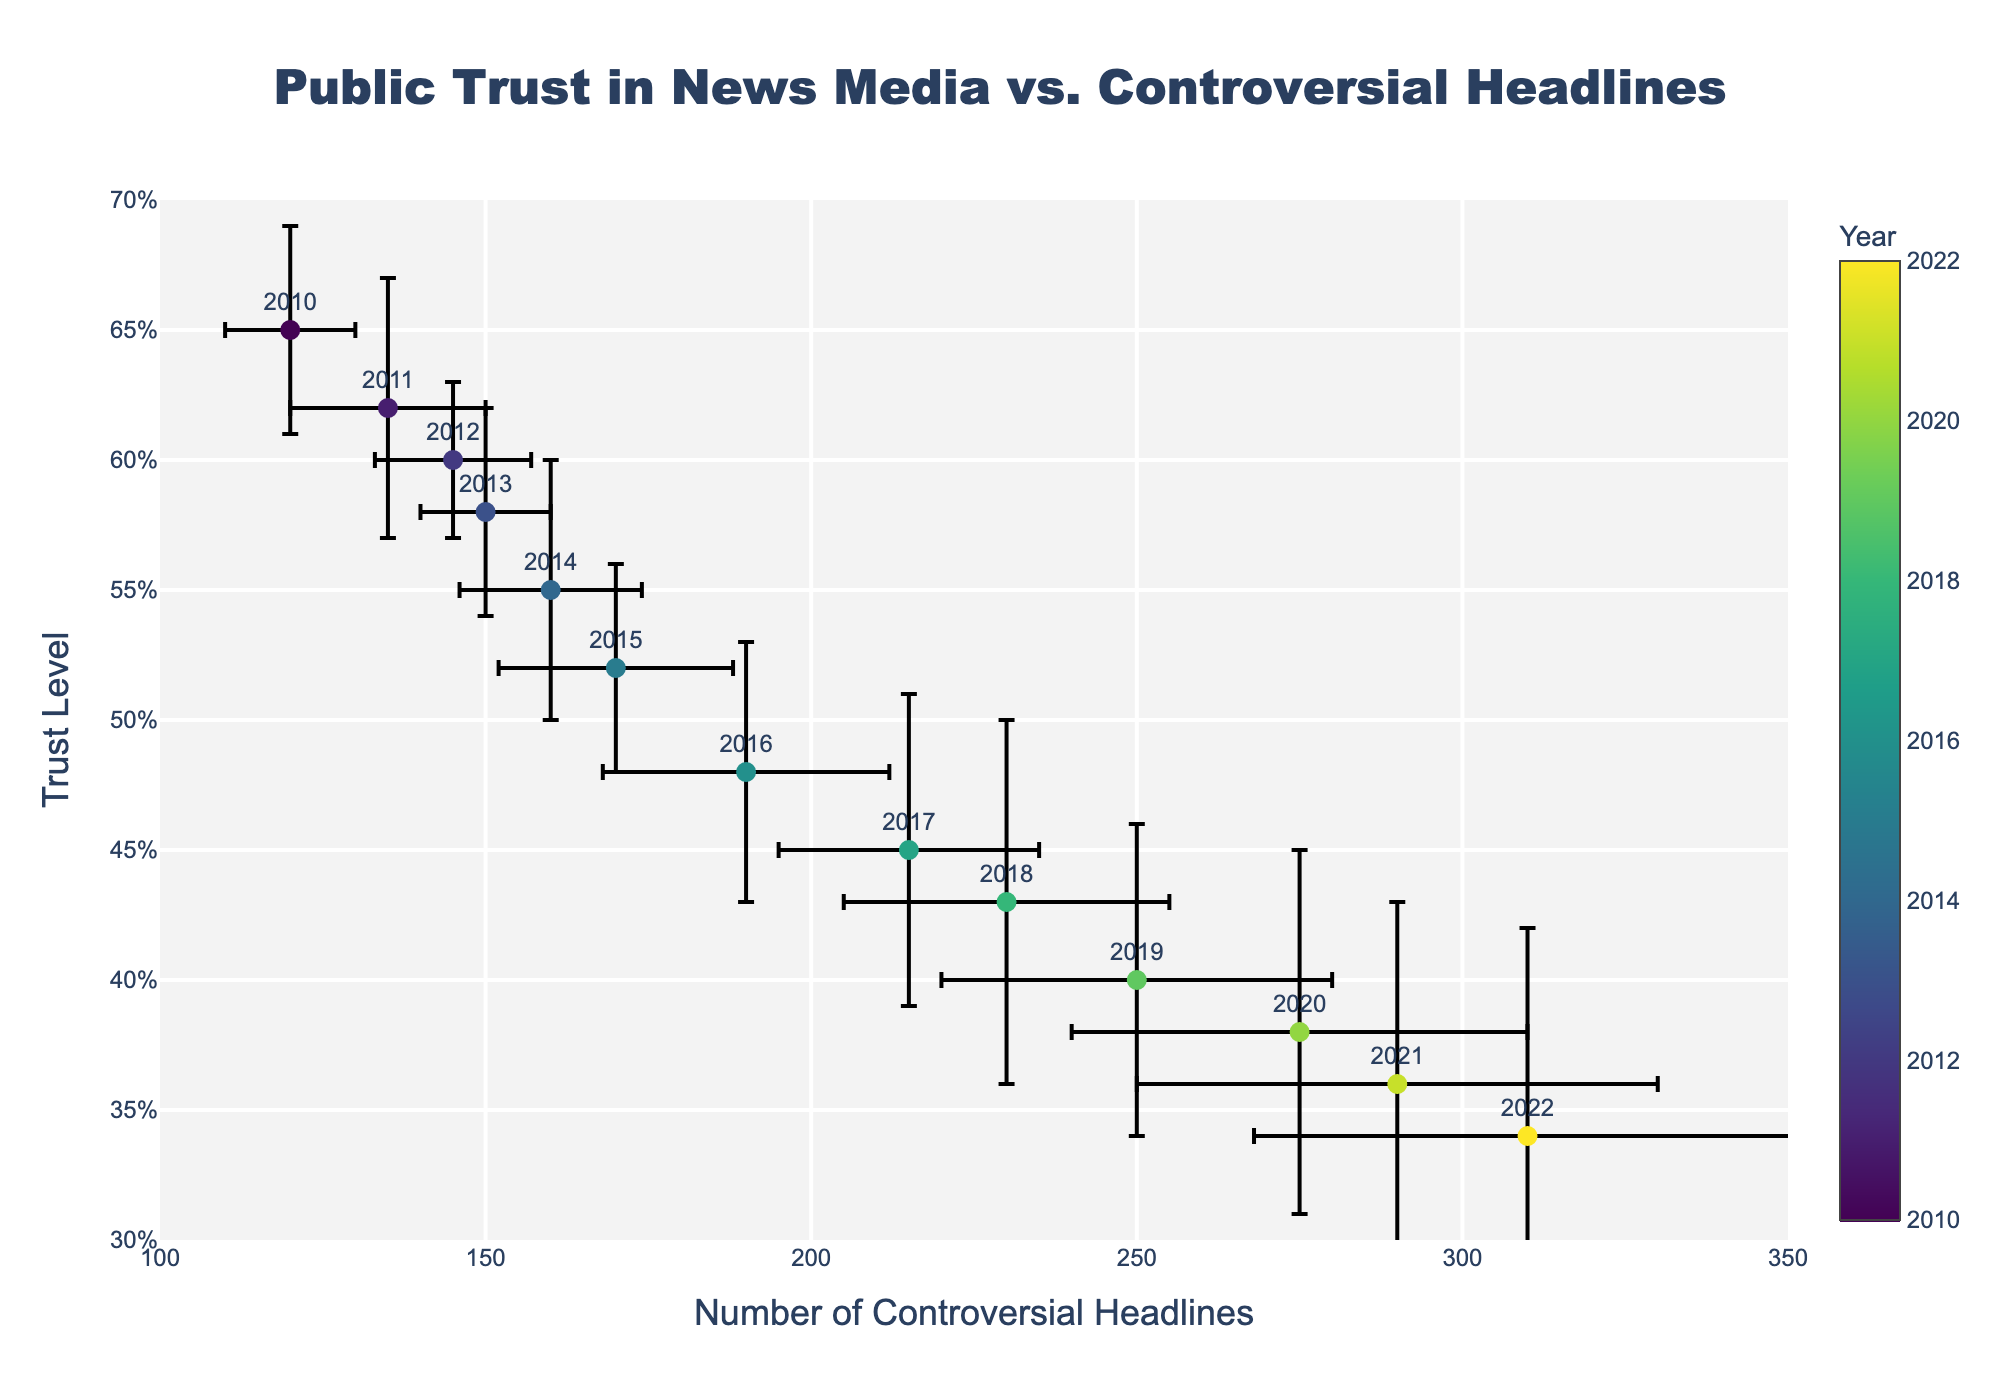What is the title of the plot? The title is displayed at the top center of the plot and reads "Public Trust in News Media vs. Controversial Headlines"
Answer: Public Trust in News Media vs. Controversial Headlines What are the axes titles of the plot? The x-axis title is labeled "Number of Controversial Headlines" and the y-axis title is labeled "Trust Level" as seen on the respective axes.
Answer: Number of Controversial Headlines, Trust Level Around which year does the trust level drop below 0.40 for the first time? From the plot, the trust level first drops below 0.40 in the year 2019, as indicated by the marker color and the accompanying year label.
Answer: 2019 How does the number of controversial headlines change from 2015 to 2016? Observing the data points for 2015 and 2016, the number of controversial headlines increased from 170 in 2015 to 190 in 2016. This can be determined by the position of the markers on the x-axis.
Answer: Increased by 20 What is the approximate trust level in 2012? The marker for the year 2012 shows a trust level of approximately 0.60, found by looking at the y-coordinate of the marker labeled "2012" on the plot.
Answer: 0.60 Which year has the highest number of controversial headlines? By examining the plot, the year 2022 has the highest number of controversial headlines, as indicated by the position of the marker farthest to the right on the x-axis.
Answer: 2022 What is the general trend between the number of controversial headlines and the trust level over time? The plot shows a negative trend where the trust level decreases as the number of controversial headlines increases, which is visually evident by the downward slope from left to right.
Answer: Negative trend How large is the error margin for the number of controversial headlines in 2021? In the plot, the error bar for the year 2021 extends from around 250 to 330, indicating an error margin of approximately 40.
Answer: 40 Compare the trust level error margins in 2010 and 2020. The plot shows that the trust level error margin for 2010 is narrower (0.04) compared to 2020, which has a wider error margin (0.07), as seen from the lengths of the error bars for these years.
Answer: 2010 has a smaller error margin Does the plot suggest that controversial headlines have a direct impact on public trust levels over time? Yes, the overall negative trend in the plot, where higher numbers of controversial headlines correspond with lower trust levels, suggests a potential direct impact on public trust levels over time.
Answer: Yes 